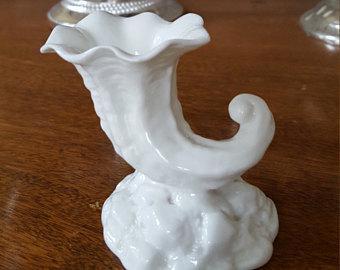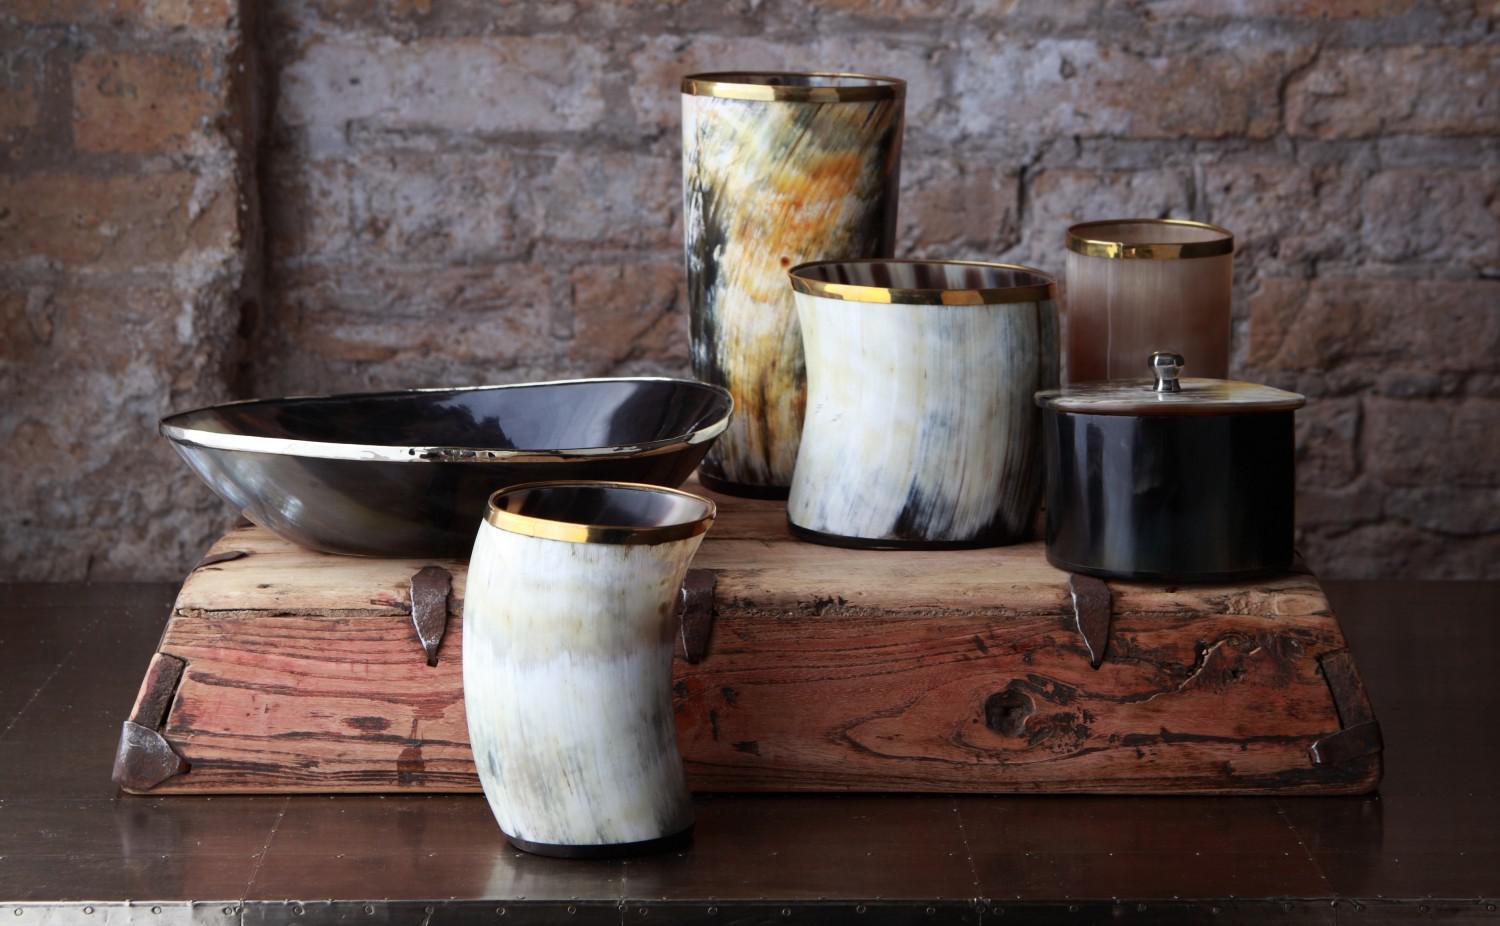The first image is the image on the left, the second image is the image on the right. Assess this claim about the two images: "One of the images shows two identical vases next to each other.". Correct or not? Answer yes or no. No. The first image is the image on the left, the second image is the image on the right. Considering the images on both sides, is "The vases have a floral theme on the front" valid? Answer yes or no. No. 